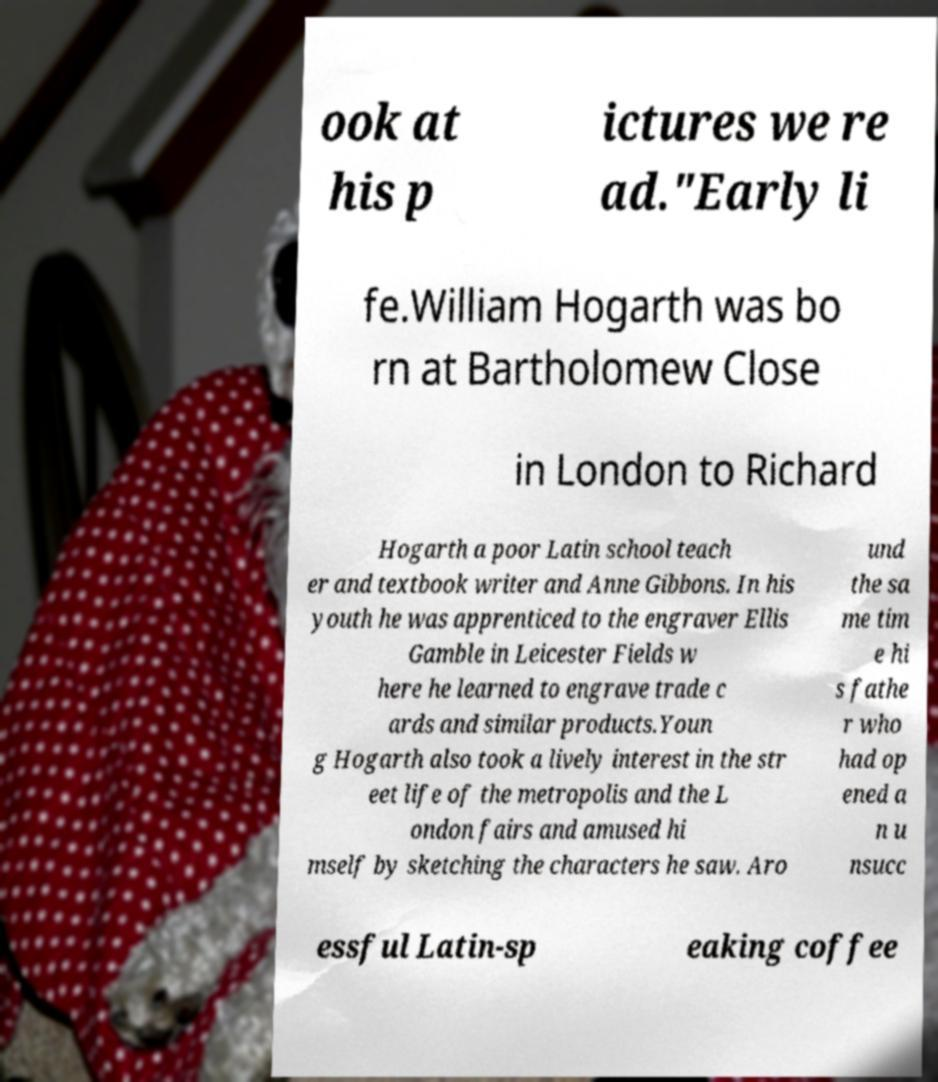What messages or text are displayed in this image? I need them in a readable, typed format. ook at his p ictures we re ad."Early li fe.William Hogarth was bo rn at Bartholomew Close in London to Richard Hogarth a poor Latin school teach er and textbook writer and Anne Gibbons. In his youth he was apprenticed to the engraver Ellis Gamble in Leicester Fields w here he learned to engrave trade c ards and similar products.Youn g Hogarth also took a lively interest in the str eet life of the metropolis and the L ondon fairs and amused hi mself by sketching the characters he saw. Aro und the sa me tim e hi s fathe r who had op ened a n u nsucc essful Latin-sp eaking coffee 